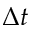<formula> <loc_0><loc_0><loc_500><loc_500>\Delta t</formula> 